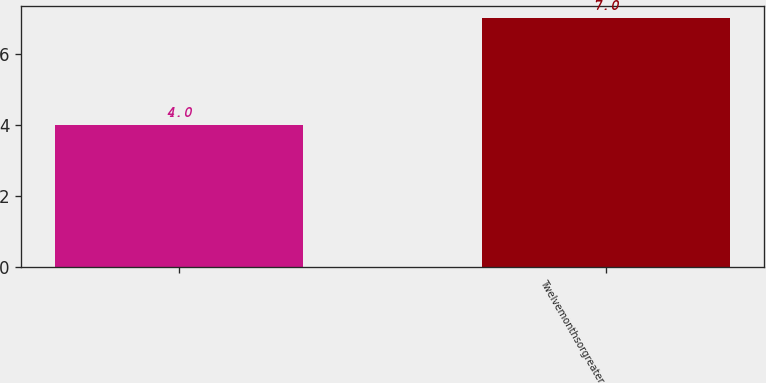Convert chart to OTSL. <chart><loc_0><loc_0><loc_500><loc_500><bar_chart><ecel><fcel>Twelvemonthsorgreater<nl><fcel>4<fcel>7<nl></chart> 